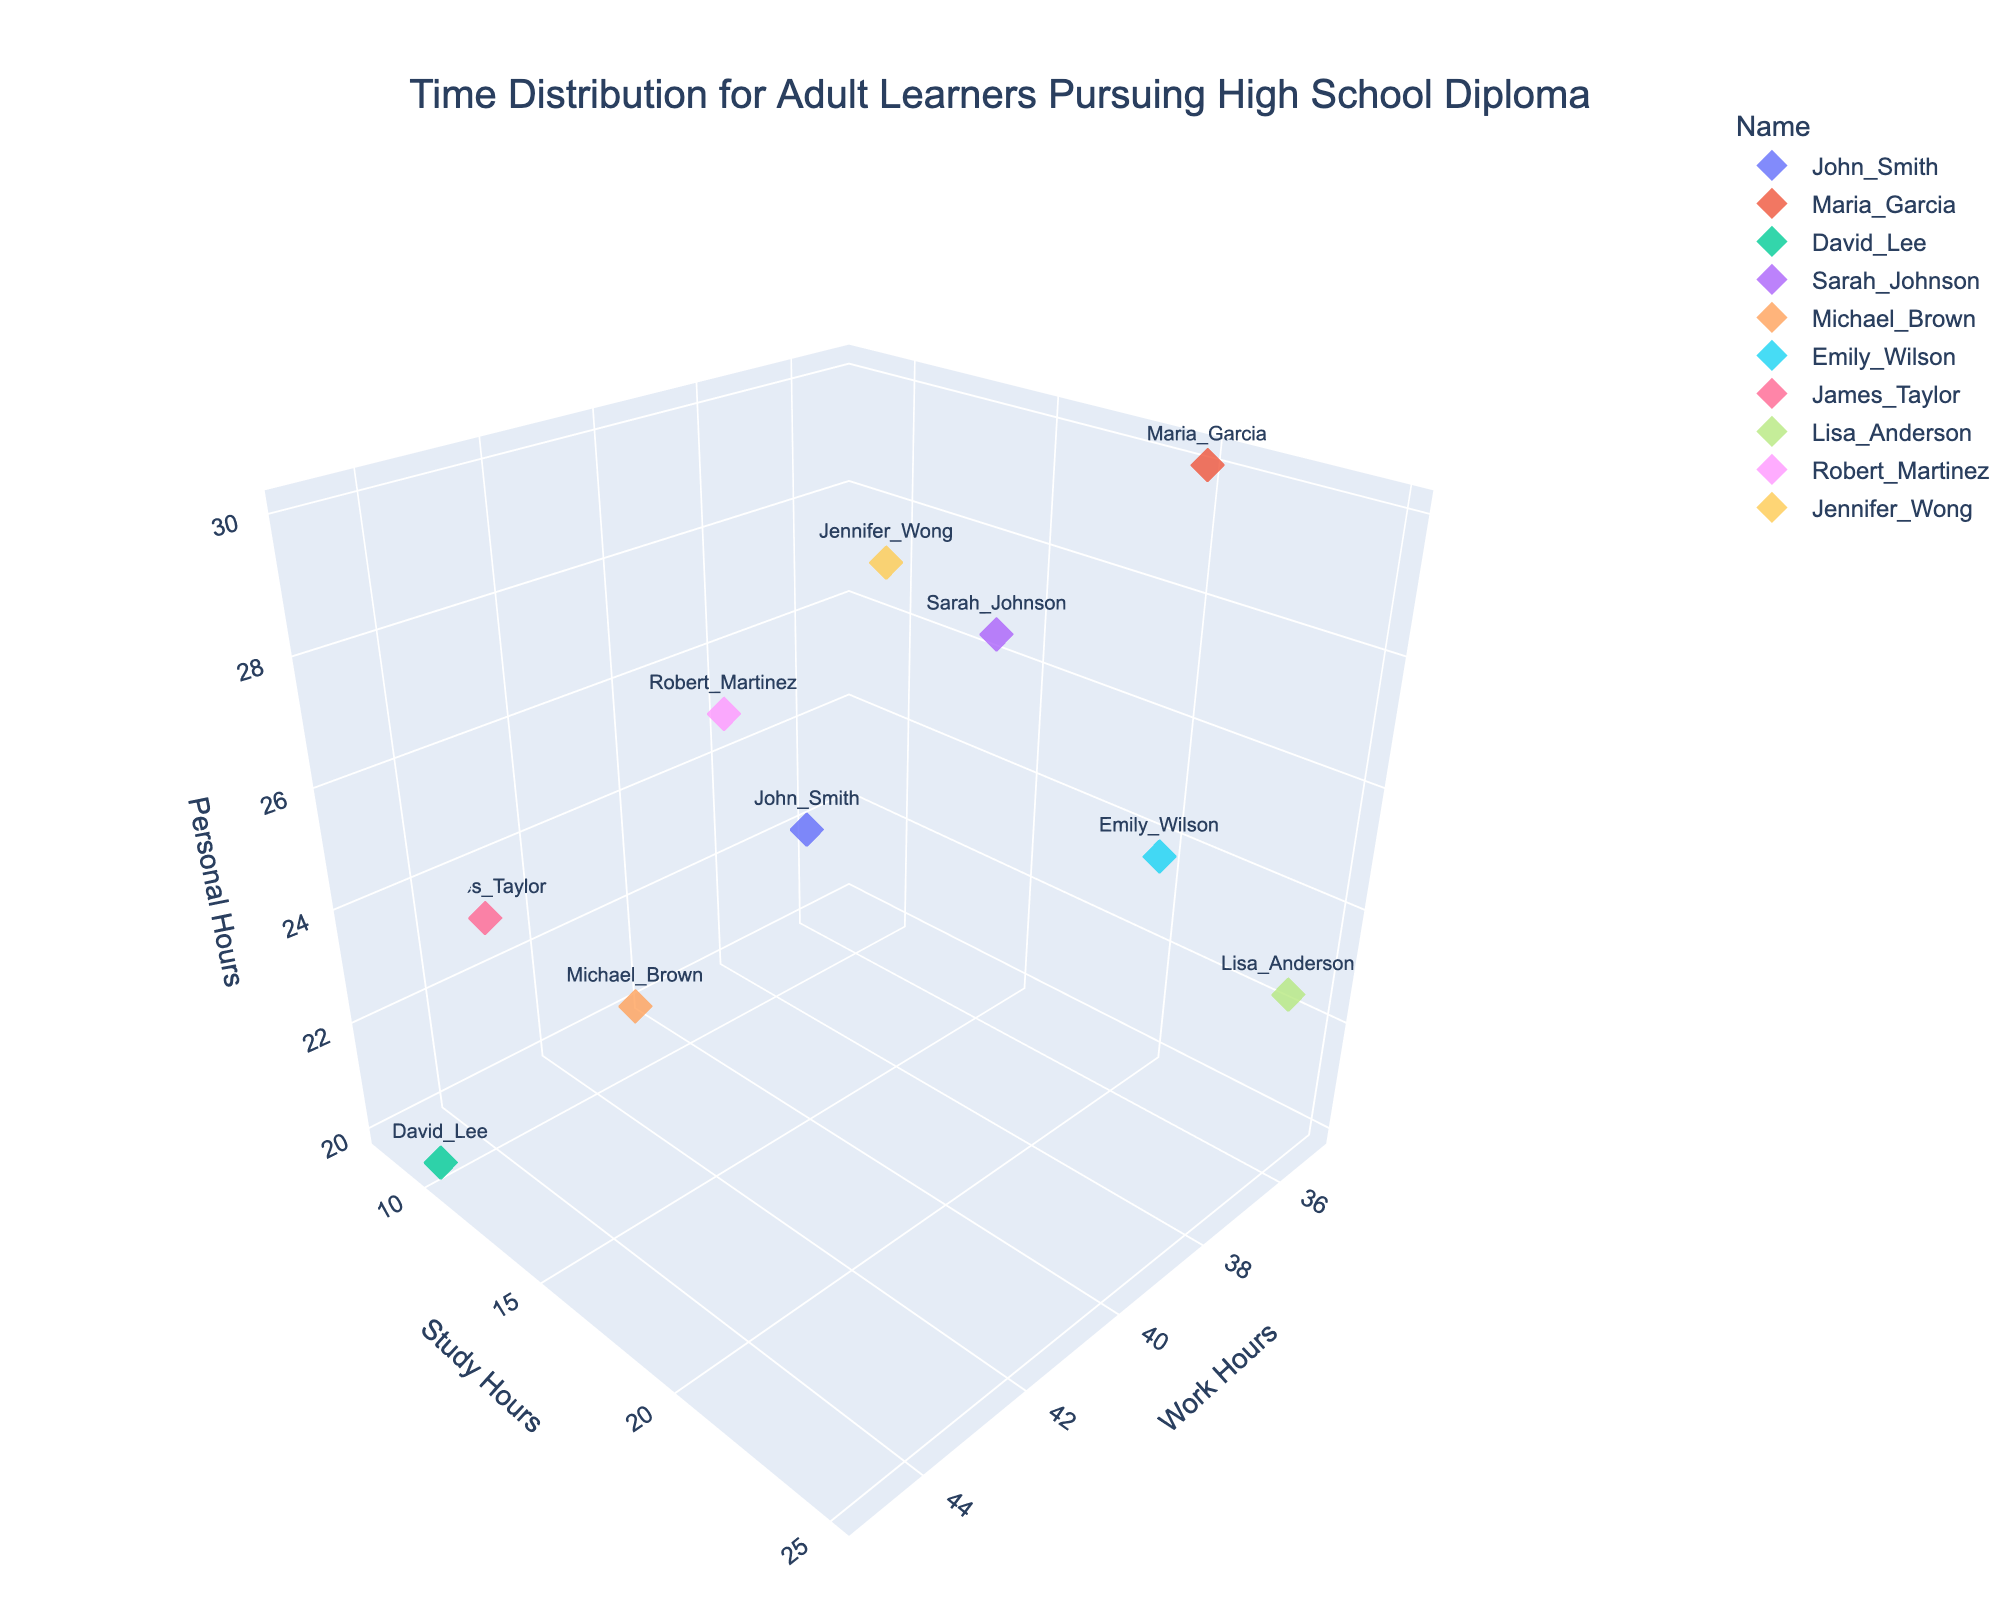What is the title of the figure? The title of the figure is displayed at the top of the graph.
Answer: Time Distribution for Adult Learners Pursuing High School Diploma How many data points are represented in the 3D scatter plot? The number of distinct colored markers in the plot represents the total data points.
Answer: 10 Which individual spends the most hours working? Look for the data point with the highest value along the 'Work Hours' axis.
Answer: David Lee Who spends the most time studying? Find the data point with the highest value on the 'Study Hours' axis.
Answer: Lisa Anderson Who has the least amount of personal hours? Find the data point with the lowest value on the 'Personal Hours' axis.
Answer: David Lee What is the sum of work hours and study hours for Sarah Johnson? Add the 'Work Hours' and 'Study Hours' values for Sarah Johnson. Sarah's data point has Work_Hours=38 and Study_Hours=18. So, the sum is 38 + 18 = 56.
Answer: 56 Compare the work hours of John Smith and Maria Garcia. Who spends more time working? Check the 'Work Hours' axis values for John Smith and Maria Garcia and compare them. John Smith has 40 hours, and Maria Garcia has 35 hours.
Answer: John Smith Which individual balances their time most evenly between work, study, and personal activities? Look for a data point that has relatively equal values for 'Work Hours,' 'Study Hours,' and 'Personal Hours' compared to others.
Answer: Maria Garcia Among James Taylor and Michael Brown, who spends more time on personal activities? Compare the 'Personal Hours' values of the data points for James Taylor and Michael Brown. James Taylor spends 23 hours, and Michael Brown spends 22 hours.
Answer: James Taylor 